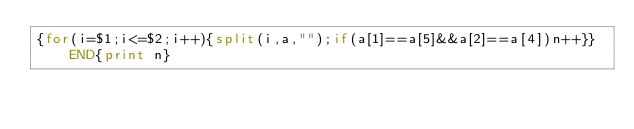Convert code to text. <code><loc_0><loc_0><loc_500><loc_500><_Awk_>{for(i=$1;i<=$2;i++){split(i,a,"");if(a[1]==a[5]&&a[2]==a[4])n++}}END{print n}</code> 